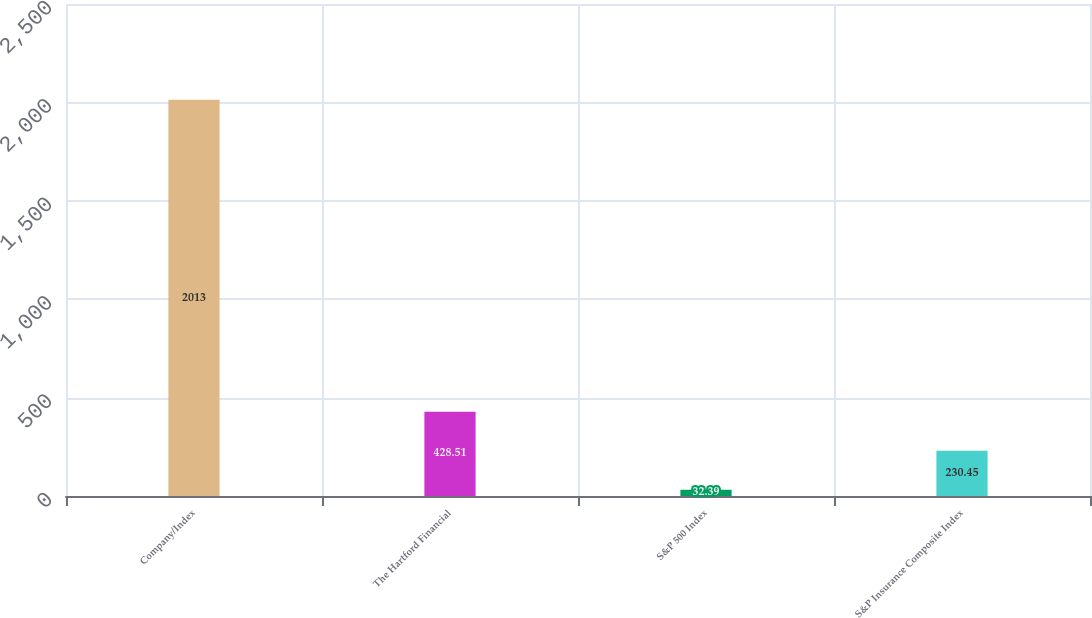<chart> <loc_0><loc_0><loc_500><loc_500><bar_chart><fcel>Company/Index<fcel>The Hartford Financial<fcel>S&P 500 Index<fcel>S&P Insurance Composite Index<nl><fcel>2013<fcel>428.51<fcel>32.39<fcel>230.45<nl></chart> 